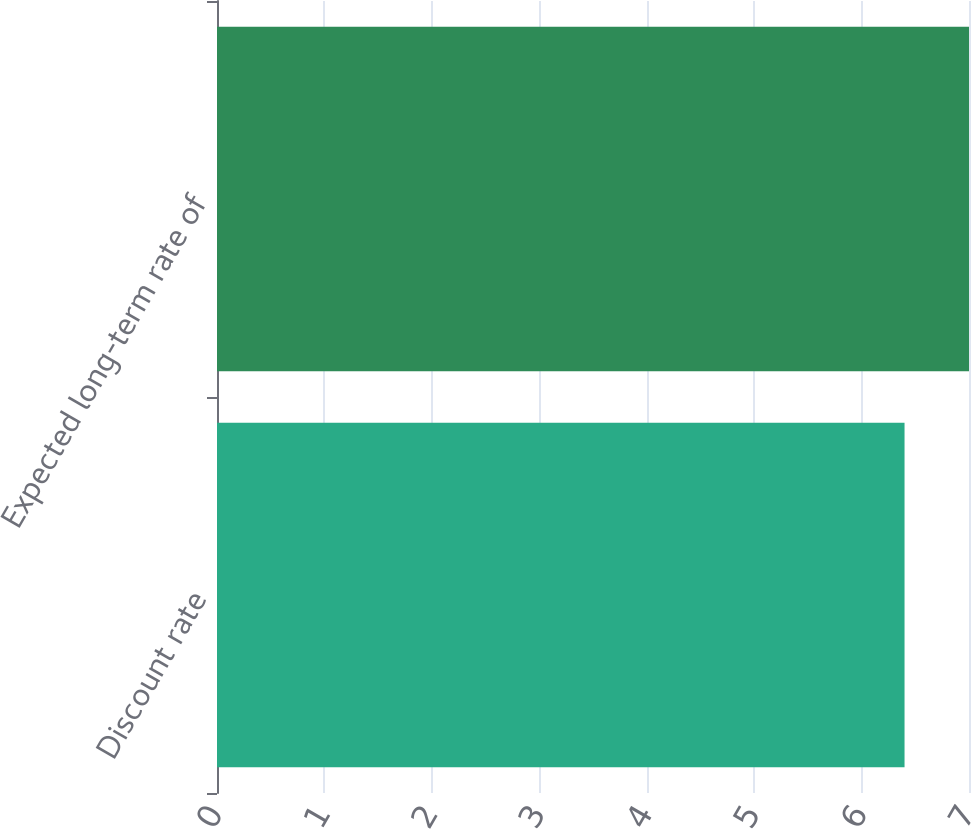Convert chart. <chart><loc_0><loc_0><loc_500><loc_500><bar_chart><fcel>Discount rate<fcel>Expected long-term rate of<nl><fcel>6.4<fcel>7<nl></chart> 